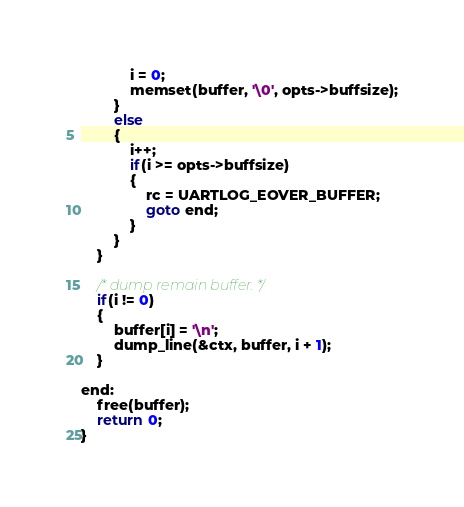Convert code to text. <code><loc_0><loc_0><loc_500><loc_500><_C_>			i = 0;
			memset(buffer, '\0', opts->buffsize);
		}
		else 
		{
			i++;
			if(i >= opts->buffsize)
			{
				rc = UARTLOG_EOVER_BUFFER;
				goto end;
			}
		}
	}

	/* dump remain buffer. */
	if(i != 0)
	{
		buffer[i] = '\n';
		dump_line(&ctx, buffer, i + 1);
	}

end:
	free(buffer);
	return 0;
}
</code> 